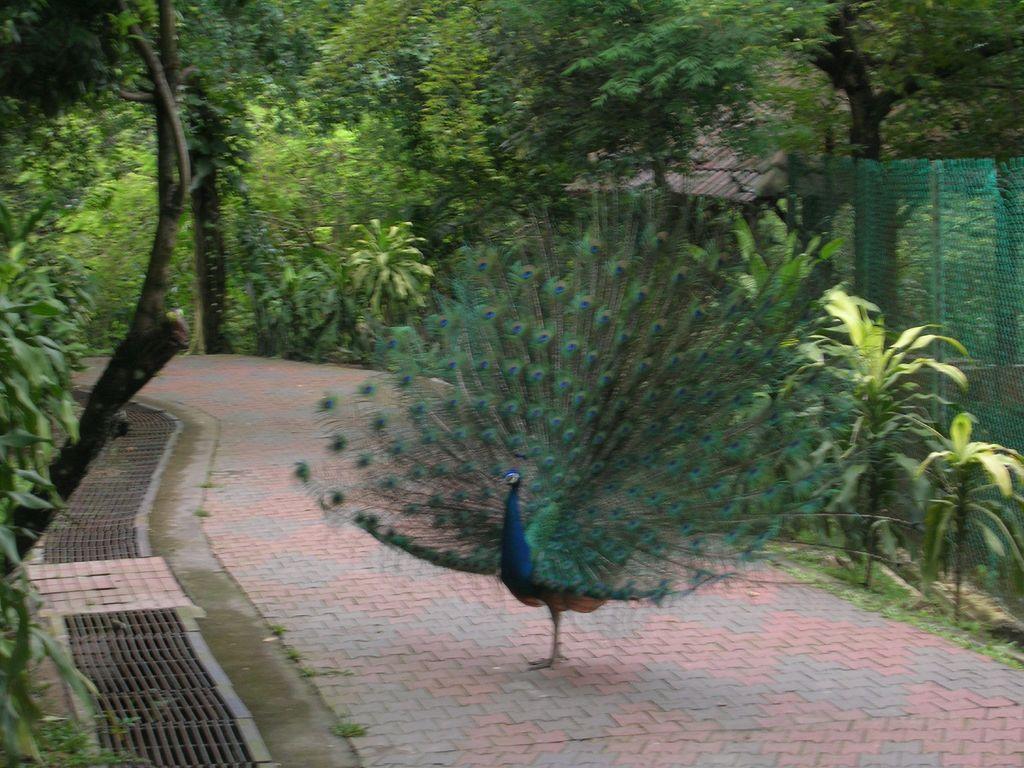Could you give a brief overview of what you see in this image? In this picture we can see a peacock on the path. There are a few plants, fence and a house is visible on the right side. We can see brown objects on the path. We can see some trees in the background. 